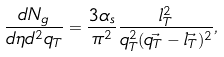Convert formula to latex. <formula><loc_0><loc_0><loc_500><loc_500>\frac { d N _ { g } } { d \eta d ^ { 2 } q _ { T } } = \frac { 3 \alpha _ { s } } { \pi ^ { 2 } } \frac { l _ { T } ^ { 2 } } { q _ { T } ^ { 2 } ( \vec { q _ { T } } - \vec { l _ { T } } ) ^ { 2 } } ,</formula> 